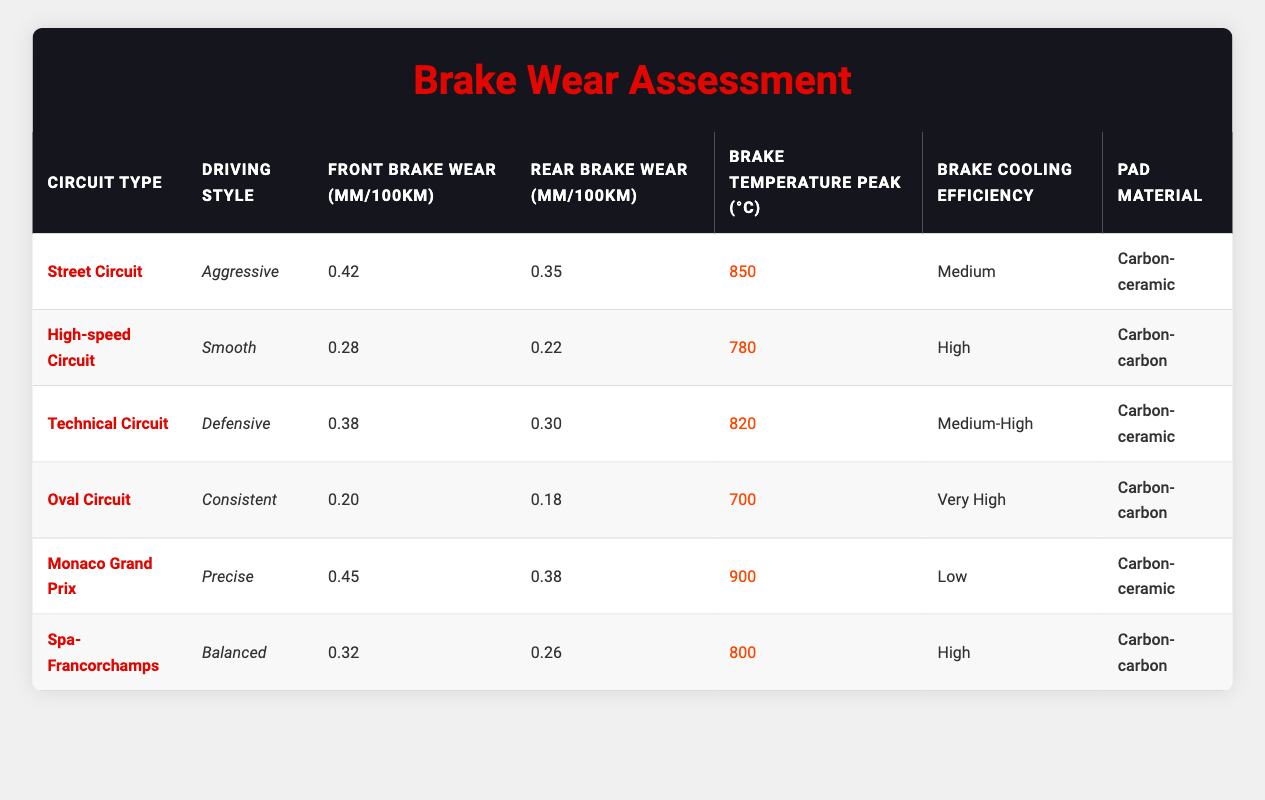What is the front brake wear for the Monaco Grand Prix? The table shows that for the Monaco Grand Prix, the front brake wear is listed as 0.45 mm/100km.
Answer: 0.45 mm/100km Which circuit type has the highest peak brake temperature and what is that temperature? According to the table, the Monaco Grand Prix has the highest peak brake temperature at 900 °C.
Answer: 900 °C What is the average rear brake wear across all circuit types? To find the average rear brake wear, sum the rear brake wear values (0.35 + 0.22 + 0.30 + 0.18 + 0.38 + 0.26) = 1.69 mm/100km. There are 6 data points, so the average is 1.69/6 = 0.28167 mm/100km, rounded to 0.28 mm/100km.
Answer: 0.28 mm/100km Is the brake cooling efficiency described as "Low" for any circuit type? Yes, the table indicates that the Monaco Grand Prix has a brake cooling efficiency described as "Low."
Answer: Yes Which driving style results in the least front brake wear, and what is that wear? The table indicates that the "Consistent" driving style on the Oval Circuit results in the least front brake wear at 0.20 mm/100km.
Answer: 0.20 mm/100km Which two circuit types have the same pad material, and what is that material? The Street Circuit and Technical Circuit both use "Carbon-ceramic" as their pad material, as shown in the table.
Answer: Carbon-ceramic What is the difference in front brake wear between Aggressive and Smooth driving styles? The front brake wear for Aggressive driving style (Street Circuit) is 0.42 mm/100km and for Smooth driving style (High-speed Circuit) is 0.28 mm/100km. The difference is 0.42 - 0.28 = 0.14 mm/100km.
Answer: 0.14 mm/100km Which circuit type, based on the data, has the best brake cooling efficiency? Based on the table, the Oval Circuit has the best brake cooling efficiency labeled as "Very high."
Answer: Very high What is the most common pad material used across the circuits in the table? The table shows that "Carbon-ceramic" is used in 3 out of the 6 entries, while "Carbon-carbon" is also used 3 times, making them equally common.
Answer: Both Carbon-ceramic and Carbon-carbon 